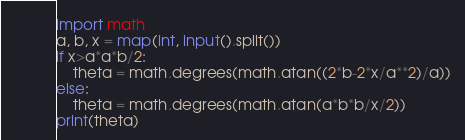<code> <loc_0><loc_0><loc_500><loc_500><_Python_>import math
a, b, x = map(int, input().split())
if x>a*a*b/2:
    theta = math.degrees(math.atan((2*b-2*x/a**2)/a))
else:
    theta = math.degrees(math.atan(a*b*b/x/2))
print(theta)</code> 